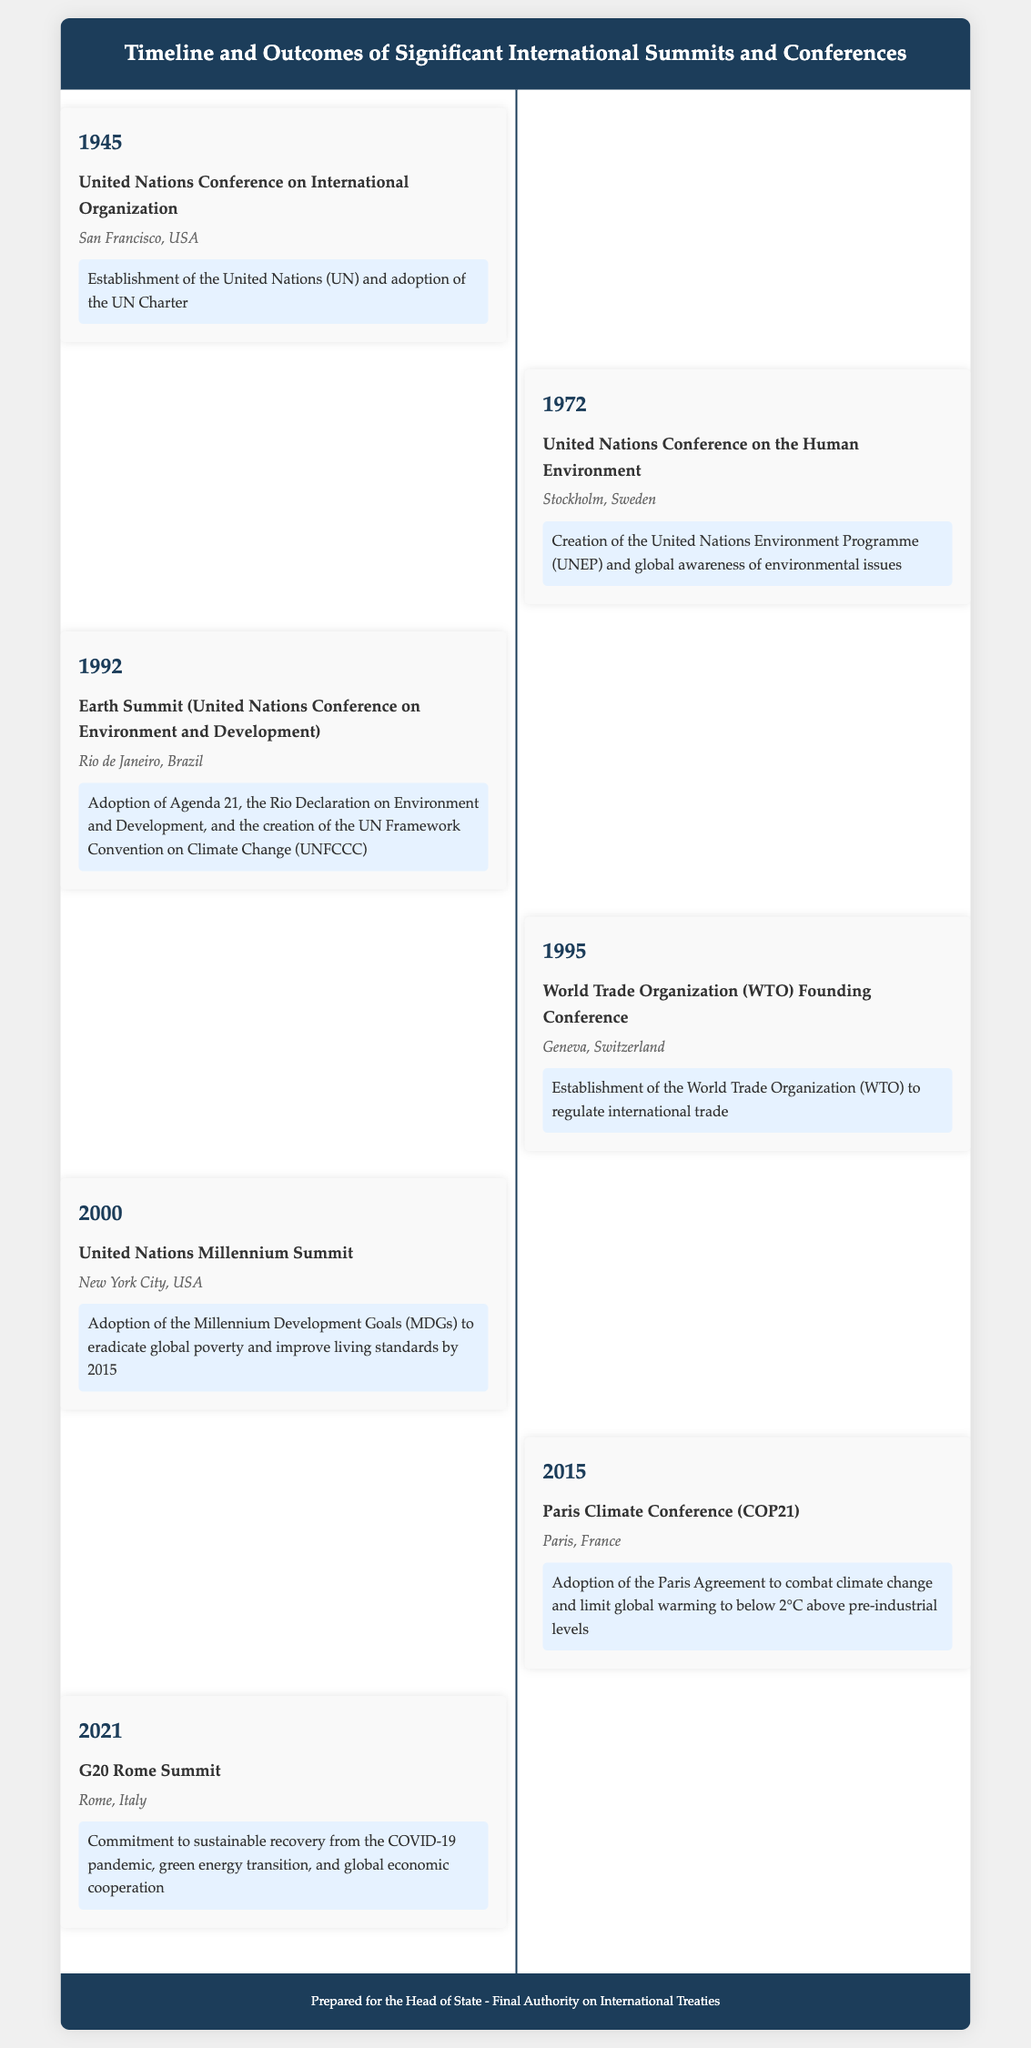What year was the United Nations Conference on International Organization held? The document states that this summit took place in 1945.
Answer: 1945 What is the main outcome of the Earth Summit in 1992? The document mentions that it was the adoption of Agenda 21 and the creation of the UN Framework Convention on Climate Change.
Answer: Adoption of Agenda 21 Where was the World Trade Organization founding conference held? According to the document, the founding conference took place in Geneva, Switzerland.
Answer: Geneva, Switzerland Which summit resulted in the establishment of the United Nations Environment Programme? The document indicates this was the outcome of the United Nations Conference on the Human Environment held in 1972.
Answer: 1972 What is the location of the Paris Climate Conference? The document states that the conference was held in Paris, France.
Answer: Paris, France What global commitment was made at the G20 Rome Summit in 2021? The document mentions a commitment to sustainable recovery and green energy transition.
Answer: Sustainable recovery How many significant events are listed in the document? The document shows seven significant international summits and conferences.
Answer: Seven What international treaty came from the Paris Climate Conference? The outcome listed for this conference is the adoption of the Paris Agreement.
Answer: Paris Agreement Which event culminated in the establishment of the World Trade Organization? The document specifies that the World Trade Organization Founding Conference led to its establishment.
Answer: World Trade Organization Founding Conference 